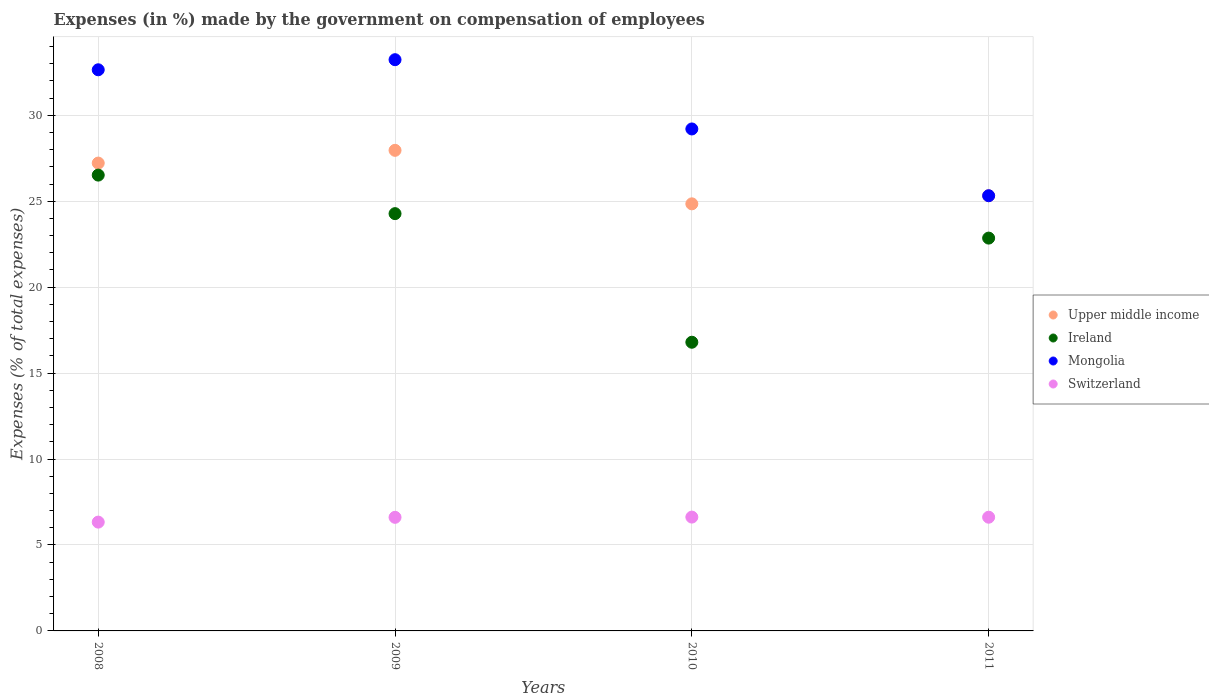How many different coloured dotlines are there?
Make the answer very short. 4. What is the percentage of expenses made by the government on compensation of employees in Switzerland in 2009?
Provide a short and direct response. 6.61. Across all years, what is the maximum percentage of expenses made by the government on compensation of employees in Switzerland?
Keep it short and to the point. 6.62. Across all years, what is the minimum percentage of expenses made by the government on compensation of employees in Mongolia?
Offer a very short reply. 25.32. In which year was the percentage of expenses made by the government on compensation of employees in Ireland maximum?
Keep it short and to the point. 2008. What is the total percentage of expenses made by the government on compensation of employees in Switzerland in the graph?
Make the answer very short. 26.18. What is the difference between the percentage of expenses made by the government on compensation of employees in Switzerland in 2008 and that in 2010?
Your response must be concise. -0.29. What is the difference between the percentage of expenses made by the government on compensation of employees in Mongolia in 2011 and the percentage of expenses made by the government on compensation of employees in Switzerland in 2008?
Offer a terse response. 18.99. What is the average percentage of expenses made by the government on compensation of employees in Mongolia per year?
Make the answer very short. 30.1. In the year 2010, what is the difference between the percentage of expenses made by the government on compensation of employees in Switzerland and percentage of expenses made by the government on compensation of employees in Mongolia?
Offer a very short reply. -22.58. In how many years, is the percentage of expenses made by the government on compensation of employees in Mongolia greater than 14 %?
Keep it short and to the point. 4. What is the ratio of the percentage of expenses made by the government on compensation of employees in Switzerland in 2009 to that in 2011?
Give a very brief answer. 1. Is the percentage of expenses made by the government on compensation of employees in Switzerland in 2009 less than that in 2010?
Offer a terse response. Yes. Is the difference between the percentage of expenses made by the government on compensation of employees in Switzerland in 2009 and 2010 greater than the difference between the percentage of expenses made by the government on compensation of employees in Mongolia in 2009 and 2010?
Provide a succinct answer. No. What is the difference between the highest and the second highest percentage of expenses made by the government on compensation of employees in Switzerland?
Offer a terse response. 0.01. What is the difference between the highest and the lowest percentage of expenses made by the government on compensation of employees in Mongolia?
Offer a terse response. 7.92. Is the percentage of expenses made by the government on compensation of employees in Switzerland strictly greater than the percentage of expenses made by the government on compensation of employees in Mongolia over the years?
Offer a terse response. No. Is the percentage of expenses made by the government on compensation of employees in Mongolia strictly less than the percentage of expenses made by the government on compensation of employees in Ireland over the years?
Give a very brief answer. No. How many dotlines are there?
Make the answer very short. 4. How many years are there in the graph?
Give a very brief answer. 4. What is the difference between two consecutive major ticks on the Y-axis?
Give a very brief answer. 5. Are the values on the major ticks of Y-axis written in scientific E-notation?
Give a very brief answer. No. Does the graph contain any zero values?
Offer a terse response. No. Does the graph contain grids?
Provide a short and direct response. Yes. How are the legend labels stacked?
Offer a very short reply. Vertical. What is the title of the graph?
Keep it short and to the point. Expenses (in %) made by the government on compensation of employees. Does "Thailand" appear as one of the legend labels in the graph?
Offer a very short reply. No. What is the label or title of the X-axis?
Offer a very short reply. Years. What is the label or title of the Y-axis?
Ensure brevity in your answer.  Expenses (% of total expenses). What is the Expenses (% of total expenses) of Upper middle income in 2008?
Ensure brevity in your answer.  27.22. What is the Expenses (% of total expenses) in Ireland in 2008?
Ensure brevity in your answer.  26.52. What is the Expenses (% of total expenses) in Mongolia in 2008?
Give a very brief answer. 32.65. What is the Expenses (% of total expenses) of Switzerland in 2008?
Keep it short and to the point. 6.33. What is the Expenses (% of total expenses) in Upper middle income in 2009?
Give a very brief answer. 27.96. What is the Expenses (% of total expenses) of Ireland in 2009?
Your answer should be compact. 24.28. What is the Expenses (% of total expenses) in Mongolia in 2009?
Ensure brevity in your answer.  33.24. What is the Expenses (% of total expenses) of Switzerland in 2009?
Provide a short and direct response. 6.61. What is the Expenses (% of total expenses) of Upper middle income in 2010?
Make the answer very short. 24.85. What is the Expenses (% of total expenses) in Ireland in 2010?
Offer a very short reply. 16.8. What is the Expenses (% of total expenses) of Mongolia in 2010?
Your answer should be very brief. 29.21. What is the Expenses (% of total expenses) of Switzerland in 2010?
Offer a terse response. 6.62. What is the Expenses (% of total expenses) in Upper middle income in 2011?
Make the answer very short. 25.32. What is the Expenses (% of total expenses) of Ireland in 2011?
Offer a terse response. 22.86. What is the Expenses (% of total expenses) in Mongolia in 2011?
Keep it short and to the point. 25.32. What is the Expenses (% of total expenses) of Switzerland in 2011?
Ensure brevity in your answer.  6.62. Across all years, what is the maximum Expenses (% of total expenses) of Upper middle income?
Provide a short and direct response. 27.96. Across all years, what is the maximum Expenses (% of total expenses) in Ireland?
Ensure brevity in your answer.  26.52. Across all years, what is the maximum Expenses (% of total expenses) in Mongolia?
Keep it short and to the point. 33.24. Across all years, what is the maximum Expenses (% of total expenses) of Switzerland?
Offer a very short reply. 6.62. Across all years, what is the minimum Expenses (% of total expenses) in Upper middle income?
Your answer should be very brief. 24.85. Across all years, what is the minimum Expenses (% of total expenses) in Ireland?
Provide a succinct answer. 16.8. Across all years, what is the minimum Expenses (% of total expenses) in Mongolia?
Your answer should be compact. 25.32. Across all years, what is the minimum Expenses (% of total expenses) in Switzerland?
Your answer should be compact. 6.33. What is the total Expenses (% of total expenses) in Upper middle income in the graph?
Keep it short and to the point. 105.35. What is the total Expenses (% of total expenses) of Ireland in the graph?
Your response must be concise. 90.45. What is the total Expenses (% of total expenses) of Mongolia in the graph?
Provide a succinct answer. 120.41. What is the total Expenses (% of total expenses) in Switzerland in the graph?
Make the answer very short. 26.18. What is the difference between the Expenses (% of total expenses) of Upper middle income in 2008 and that in 2009?
Offer a terse response. -0.74. What is the difference between the Expenses (% of total expenses) of Ireland in 2008 and that in 2009?
Make the answer very short. 2.24. What is the difference between the Expenses (% of total expenses) in Mongolia in 2008 and that in 2009?
Make the answer very short. -0.59. What is the difference between the Expenses (% of total expenses) in Switzerland in 2008 and that in 2009?
Make the answer very short. -0.28. What is the difference between the Expenses (% of total expenses) of Upper middle income in 2008 and that in 2010?
Your response must be concise. 2.37. What is the difference between the Expenses (% of total expenses) in Ireland in 2008 and that in 2010?
Offer a very short reply. 9.72. What is the difference between the Expenses (% of total expenses) in Mongolia in 2008 and that in 2010?
Your answer should be very brief. 3.44. What is the difference between the Expenses (% of total expenses) in Switzerland in 2008 and that in 2010?
Provide a succinct answer. -0.29. What is the difference between the Expenses (% of total expenses) in Upper middle income in 2008 and that in 2011?
Ensure brevity in your answer.  1.9. What is the difference between the Expenses (% of total expenses) of Ireland in 2008 and that in 2011?
Offer a very short reply. 3.67. What is the difference between the Expenses (% of total expenses) in Mongolia in 2008 and that in 2011?
Your answer should be compact. 7.33. What is the difference between the Expenses (% of total expenses) in Switzerland in 2008 and that in 2011?
Offer a very short reply. -0.29. What is the difference between the Expenses (% of total expenses) of Upper middle income in 2009 and that in 2010?
Keep it short and to the point. 3.11. What is the difference between the Expenses (% of total expenses) in Ireland in 2009 and that in 2010?
Keep it short and to the point. 7.48. What is the difference between the Expenses (% of total expenses) of Mongolia in 2009 and that in 2010?
Offer a terse response. 4.03. What is the difference between the Expenses (% of total expenses) in Switzerland in 2009 and that in 2010?
Your answer should be compact. -0.01. What is the difference between the Expenses (% of total expenses) in Upper middle income in 2009 and that in 2011?
Your answer should be compact. 2.64. What is the difference between the Expenses (% of total expenses) of Ireland in 2009 and that in 2011?
Your response must be concise. 1.42. What is the difference between the Expenses (% of total expenses) of Mongolia in 2009 and that in 2011?
Provide a short and direct response. 7.92. What is the difference between the Expenses (% of total expenses) of Switzerland in 2009 and that in 2011?
Offer a very short reply. -0.01. What is the difference between the Expenses (% of total expenses) of Upper middle income in 2010 and that in 2011?
Your answer should be very brief. -0.47. What is the difference between the Expenses (% of total expenses) in Ireland in 2010 and that in 2011?
Your response must be concise. -6.06. What is the difference between the Expenses (% of total expenses) in Mongolia in 2010 and that in 2011?
Your answer should be very brief. 3.89. What is the difference between the Expenses (% of total expenses) of Switzerland in 2010 and that in 2011?
Make the answer very short. 0.01. What is the difference between the Expenses (% of total expenses) of Upper middle income in 2008 and the Expenses (% of total expenses) of Ireland in 2009?
Give a very brief answer. 2.94. What is the difference between the Expenses (% of total expenses) of Upper middle income in 2008 and the Expenses (% of total expenses) of Mongolia in 2009?
Offer a terse response. -6.02. What is the difference between the Expenses (% of total expenses) of Upper middle income in 2008 and the Expenses (% of total expenses) of Switzerland in 2009?
Ensure brevity in your answer.  20.61. What is the difference between the Expenses (% of total expenses) of Ireland in 2008 and the Expenses (% of total expenses) of Mongolia in 2009?
Your response must be concise. -6.71. What is the difference between the Expenses (% of total expenses) in Ireland in 2008 and the Expenses (% of total expenses) in Switzerland in 2009?
Ensure brevity in your answer.  19.91. What is the difference between the Expenses (% of total expenses) in Mongolia in 2008 and the Expenses (% of total expenses) in Switzerland in 2009?
Your answer should be compact. 26.04. What is the difference between the Expenses (% of total expenses) in Upper middle income in 2008 and the Expenses (% of total expenses) in Ireland in 2010?
Provide a short and direct response. 10.42. What is the difference between the Expenses (% of total expenses) of Upper middle income in 2008 and the Expenses (% of total expenses) of Mongolia in 2010?
Your answer should be very brief. -1.99. What is the difference between the Expenses (% of total expenses) of Upper middle income in 2008 and the Expenses (% of total expenses) of Switzerland in 2010?
Your response must be concise. 20.6. What is the difference between the Expenses (% of total expenses) of Ireland in 2008 and the Expenses (% of total expenses) of Mongolia in 2010?
Your response must be concise. -2.68. What is the difference between the Expenses (% of total expenses) of Ireland in 2008 and the Expenses (% of total expenses) of Switzerland in 2010?
Your answer should be compact. 19.9. What is the difference between the Expenses (% of total expenses) of Mongolia in 2008 and the Expenses (% of total expenses) of Switzerland in 2010?
Make the answer very short. 26.03. What is the difference between the Expenses (% of total expenses) in Upper middle income in 2008 and the Expenses (% of total expenses) in Ireland in 2011?
Make the answer very short. 4.36. What is the difference between the Expenses (% of total expenses) of Upper middle income in 2008 and the Expenses (% of total expenses) of Mongolia in 2011?
Give a very brief answer. 1.9. What is the difference between the Expenses (% of total expenses) of Upper middle income in 2008 and the Expenses (% of total expenses) of Switzerland in 2011?
Give a very brief answer. 20.6. What is the difference between the Expenses (% of total expenses) of Ireland in 2008 and the Expenses (% of total expenses) of Mongolia in 2011?
Provide a succinct answer. 1.2. What is the difference between the Expenses (% of total expenses) in Ireland in 2008 and the Expenses (% of total expenses) in Switzerland in 2011?
Provide a succinct answer. 19.91. What is the difference between the Expenses (% of total expenses) of Mongolia in 2008 and the Expenses (% of total expenses) of Switzerland in 2011?
Give a very brief answer. 26.03. What is the difference between the Expenses (% of total expenses) of Upper middle income in 2009 and the Expenses (% of total expenses) of Ireland in 2010?
Keep it short and to the point. 11.17. What is the difference between the Expenses (% of total expenses) of Upper middle income in 2009 and the Expenses (% of total expenses) of Mongolia in 2010?
Give a very brief answer. -1.24. What is the difference between the Expenses (% of total expenses) of Upper middle income in 2009 and the Expenses (% of total expenses) of Switzerland in 2010?
Offer a very short reply. 21.34. What is the difference between the Expenses (% of total expenses) of Ireland in 2009 and the Expenses (% of total expenses) of Mongolia in 2010?
Offer a very short reply. -4.93. What is the difference between the Expenses (% of total expenses) of Ireland in 2009 and the Expenses (% of total expenses) of Switzerland in 2010?
Ensure brevity in your answer.  17.66. What is the difference between the Expenses (% of total expenses) in Mongolia in 2009 and the Expenses (% of total expenses) in Switzerland in 2010?
Your answer should be compact. 26.61. What is the difference between the Expenses (% of total expenses) of Upper middle income in 2009 and the Expenses (% of total expenses) of Ireland in 2011?
Your response must be concise. 5.11. What is the difference between the Expenses (% of total expenses) in Upper middle income in 2009 and the Expenses (% of total expenses) in Mongolia in 2011?
Keep it short and to the point. 2.64. What is the difference between the Expenses (% of total expenses) of Upper middle income in 2009 and the Expenses (% of total expenses) of Switzerland in 2011?
Your answer should be compact. 21.35. What is the difference between the Expenses (% of total expenses) of Ireland in 2009 and the Expenses (% of total expenses) of Mongolia in 2011?
Your answer should be very brief. -1.04. What is the difference between the Expenses (% of total expenses) of Ireland in 2009 and the Expenses (% of total expenses) of Switzerland in 2011?
Provide a succinct answer. 17.66. What is the difference between the Expenses (% of total expenses) of Mongolia in 2009 and the Expenses (% of total expenses) of Switzerland in 2011?
Your answer should be very brief. 26.62. What is the difference between the Expenses (% of total expenses) of Upper middle income in 2010 and the Expenses (% of total expenses) of Ireland in 2011?
Offer a very short reply. 1.99. What is the difference between the Expenses (% of total expenses) of Upper middle income in 2010 and the Expenses (% of total expenses) of Mongolia in 2011?
Ensure brevity in your answer.  -0.47. What is the difference between the Expenses (% of total expenses) of Upper middle income in 2010 and the Expenses (% of total expenses) of Switzerland in 2011?
Provide a succinct answer. 18.23. What is the difference between the Expenses (% of total expenses) in Ireland in 2010 and the Expenses (% of total expenses) in Mongolia in 2011?
Make the answer very short. -8.52. What is the difference between the Expenses (% of total expenses) of Ireland in 2010 and the Expenses (% of total expenses) of Switzerland in 2011?
Offer a terse response. 10.18. What is the difference between the Expenses (% of total expenses) of Mongolia in 2010 and the Expenses (% of total expenses) of Switzerland in 2011?
Offer a very short reply. 22.59. What is the average Expenses (% of total expenses) in Upper middle income per year?
Your response must be concise. 26.34. What is the average Expenses (% of total expenses) of Ireland per year?
Provide a short and direct response. 22.61. What is the average Expenses (% of total expenses) in Mongolia per year?
Ensure brevity in your answer.  30.1. What is the average Expenses (% of total expenses) in Switzerland per year?
Give a very brief answer. 6.54. In the year 2008, what is the difference between the Expenses (% of total expenses) of Upper middle income and Expenses (% of total expenses) of Ireland?
Your answer should be very brief. 0.7. In the year 2008, what is the difference between the Expenses (% of total expenses) of Upper middle income and Expenses (% of total expenses) of Mongolia?
Your answer should be very brief. -5.43. In the year 2008, what is the difference between the Expenses (% of total expenses) of Upper middle income and Expenses (% of total expenses) of Switzerland?
Provide a succinct answer. 20.89. In the year 2008, what is the difference between the Expenses (% of total expenses) in Ireland and Expenses (% of total expenses) in Mongolia?
Give a very brief answer. -6.13. In the year 2008, what is the difference between the Expenses (% of total expenses) of Ireland and Expenses (% of total expenses) of Switzerland?
Provide a succinct answer. 20.19. In the year 2008, what is the difference between the Expenses (% of total expenses) in Mongolia and Expenses (% of total expenses) in Switzerland?
Give a very brief answer. 26.32. In the year 2009, what is the difference between the Expenses (% of total expenses) of Upper middle income and Expenses (% of total expenses) of Ireland?
Make the answer very short. 3.68. In the year 2009, what is the difference between the Expenses (% of total expenses) in Upper middle income and Expenses (% of total expenses) in Mongolia?
Keep it short and to the point. -5.27. In the year 2009, what is the difference between the Expenses (% of total expenses) of Upper middle income and Expenses (% of total expenses) of Switzerland?
Ensure brevity in your answer.  21.35. In the year 2009, what is the difference between the Expenses (% of total expenses) in Ireland and Expenses (% of total expenses) in Mongolia?
Provide a succinct answer. -8.96. In the year 2009, what is the difference between the Expenses (% of total expenses) of Ireland and Expenses (% of total expenses) of Switzerland?
Keep it short and to the point. 17.67. In the year 2009, what is the difference between the Expenses (% of total expenses) of Mongolia and Expenses (% of total expenses) of Switzerland?
Your response must be concise. 26.63. In the year 2010, what is the difference between the Expenses (% of total expenses) of Upper middle income and Expenses (% of total expenses) of Ireland?
Give a very brief answer. 8.05. In the year 2010, what is the difference between the Expenses (% of total expenses) of Upper middle income and Expenses (% of total expenses) of Mongolia?
Provide a succinct answer. -4.36. In the year 2010, what is the difference between the Expenses (% of total expenses) of Upper middle income and Expenses (% of total expenses) of Switzerland?
Your answer should be very brief. 18.23. In the year 2010, what is the difference between the Expenses (% of total expenses) of Ireland and Expenses (% of total expenses) of Mongolia?
Your answer should be very brief. -12.41. In the year 2010, what is the difference between the Expenses (% of total expenses) of Ireland and Expenses (% of total expenses) of Switzerland?
Offer a terse response. 10.17. In the year 2010, what is the difference between the Expenses (% of total expenses) of Mongolia and Expenses (% of total expenses) of Switzerland?
Your answer should be compact. 22.58. In the year 2011, what is the difference between the Expenses (% of total expenses) of Upper middle income and Expenses (% of total expenses) of Ireland?
Your answer should be very brief. 2.46. In the year 2011, what is the difference between the Expenses (% of total expenses) in Upper middle income and Expenses (% of total expenses) in Mongolia?
Give a very brief answer. 0. In the year 2011, what is the difference between the Expenses (% of total expenses) in Upper middle income and Expenses (% of total expenses) in Switzerland?
Your response must be concise. 18.7. In the year 2011, what is the difference between the Expenses (% of total expenses) in Ireland and Expenses (% of total expenses) in Mongolia?
Your answer should be very brief. -2.46. In the year 2011, what is the difference between the Expenses (% of total expenses) of Ireland and Expenses (% of total expenses) of Switzerland?
Your answer should be compact. 16.24. In the year 2011, what is the difference between the Expenses (% of total expenses) in Mongolia and Expenses (% of total expenses) in Switzerland?
Make the answer very short. 18.7. What is the ratio of the Expenses (% of total expenses) of Upper middle income in 2008 to that in 2009?
Your answer should be very brief. 0.97. What is the ratio of the Expenses (% of total expenses) of Ireland in 2008 to that in 2009?
Your answer should be very brief. 1.09. What is the ratio of the Expenses (% of total expenses) in Mongolia in 2008 to that in 2009?
Offer a terse response. 0.98. What is the ratio of the Expenses (% of total expenses) of Switzerland in 2008 to that in 2009?
Provide a succinct answer. 0.96. What is the ratio of the Expenses (% of total expenses) of Upper middle income in 2008 to that in 2010?
Offer a very short reply. 1.1. What is the ratio of the Expenses (% of total expenses) of Ireland in 2008 to that in 2010?
Provide a succinct answer. 1.58. What is the ratio of the Expenses (% of total expenses) in Mongolia in 2008 to that in 2010?
Your answer should be compact. 1.12. What is the ratio of the Expenses (% of total expenses) of Switzerland in 2008 to that in 2010?
Provide a short and direct response. 0.96. What is the ratio of the Expenses (% of total expenses) of Upper middle income in 2008 to that in 2011?
Your answer should be compact. 1.07. What is the ratio of the Expenses (% of total expenses) in Ireland in 2008 to that in 2011?
Ensure brevity in your answer.  1.16. What is the ratio of the Expenses (% of total expenses) of Mongolia in 2008 to that in 2011?
Give a very brief answer. 1.29. What is the ratio of the Expenses (% of total expenses) of Switzerland in 2008 to that in 2011?
Your answer should be compact. 0.96. What is the ratio of the Expenses (% of total expenses) in Upper middle income in 2009 to that in 2010?
Make the answer very short. 1.13. What is the ratio of the Expenses (% of total expenses) in Ireland in 2009 to that in 2010?
Provide a short and direct response. 1.45. What is the ratio of the Expenses (% of total expenses) of Mongolia in 2009 to that in 2010?
Offer a terse response. 1.14. What is the ratio of the Expenses (% of total expenses) of Upper middle income in 2009 to that in 2011?
Offer a terse response. 1.1. What is the ratio of the Expenses (% of total expenses) in Ireland in 2009 to that in 2011?
Provide a succinct answer. 1.06. What is the ratio of the Expenses (% of total expenses) in Mongolia in 2009 to that in 2011?
Your answer should be very brief. 1.31. What is the ratio of the Expenses (% of total expenses) of Switzerland in 2009 to that in 2011?
Offer a terse response. 1. What is the ratio of the Expenses (% of total expenses) of Upper middle income in 2010 to that in 2011?
Provide a succinct answer. 0.98. What is the ratio of the Expenses (% of total expenses) in Ireland in 2010 to that in 2011?
Offer a very short reply. 0.73. What is the ratio of the Expenses (% of total expenses) in Mongolia in 2010 to that in 2011?
Provide a short and direct response. 1.15. What is the ratio of the Expenses (% of total expenses) of Switzerland in 2010 to that in 2011?
Your response must be concise. 1. What is the difference between the highest and the second highest Expenses (% of total expenses) of Upper middle income?
Your answer should be compact. 0.74. What is the difference between the highest and the second highest Expenses (% of total expenses) in Ireland?
Your answer should be very brief. 2.24. What is the difference between the highest and the second highest Expenses (% of total expenses) of Mongolia?
Offer a terse response. 0.59. What is the difference between the highest and the second highest Expenses (% of total expenses) in Switzerland?
Provide a short and direct response. 0.01. What is the difference between the highest and the lowest Expenses (% of total expenses) in Upper middle income?
Make the answer very short. 3.11. What is the difference between the highest and the lowest Expenses (% of total expenses) in Ireland?
Your answer should be compact. 9.72. What is the difference between the highest and the lowest Expenses (% of total expenses) in Mongolia?
Your answer should be compact. 7.92. What is the difference between the highest and the lowest Expenses (% of total expenses) of Switzerland?
Keep it short and to the point. 0.29. 